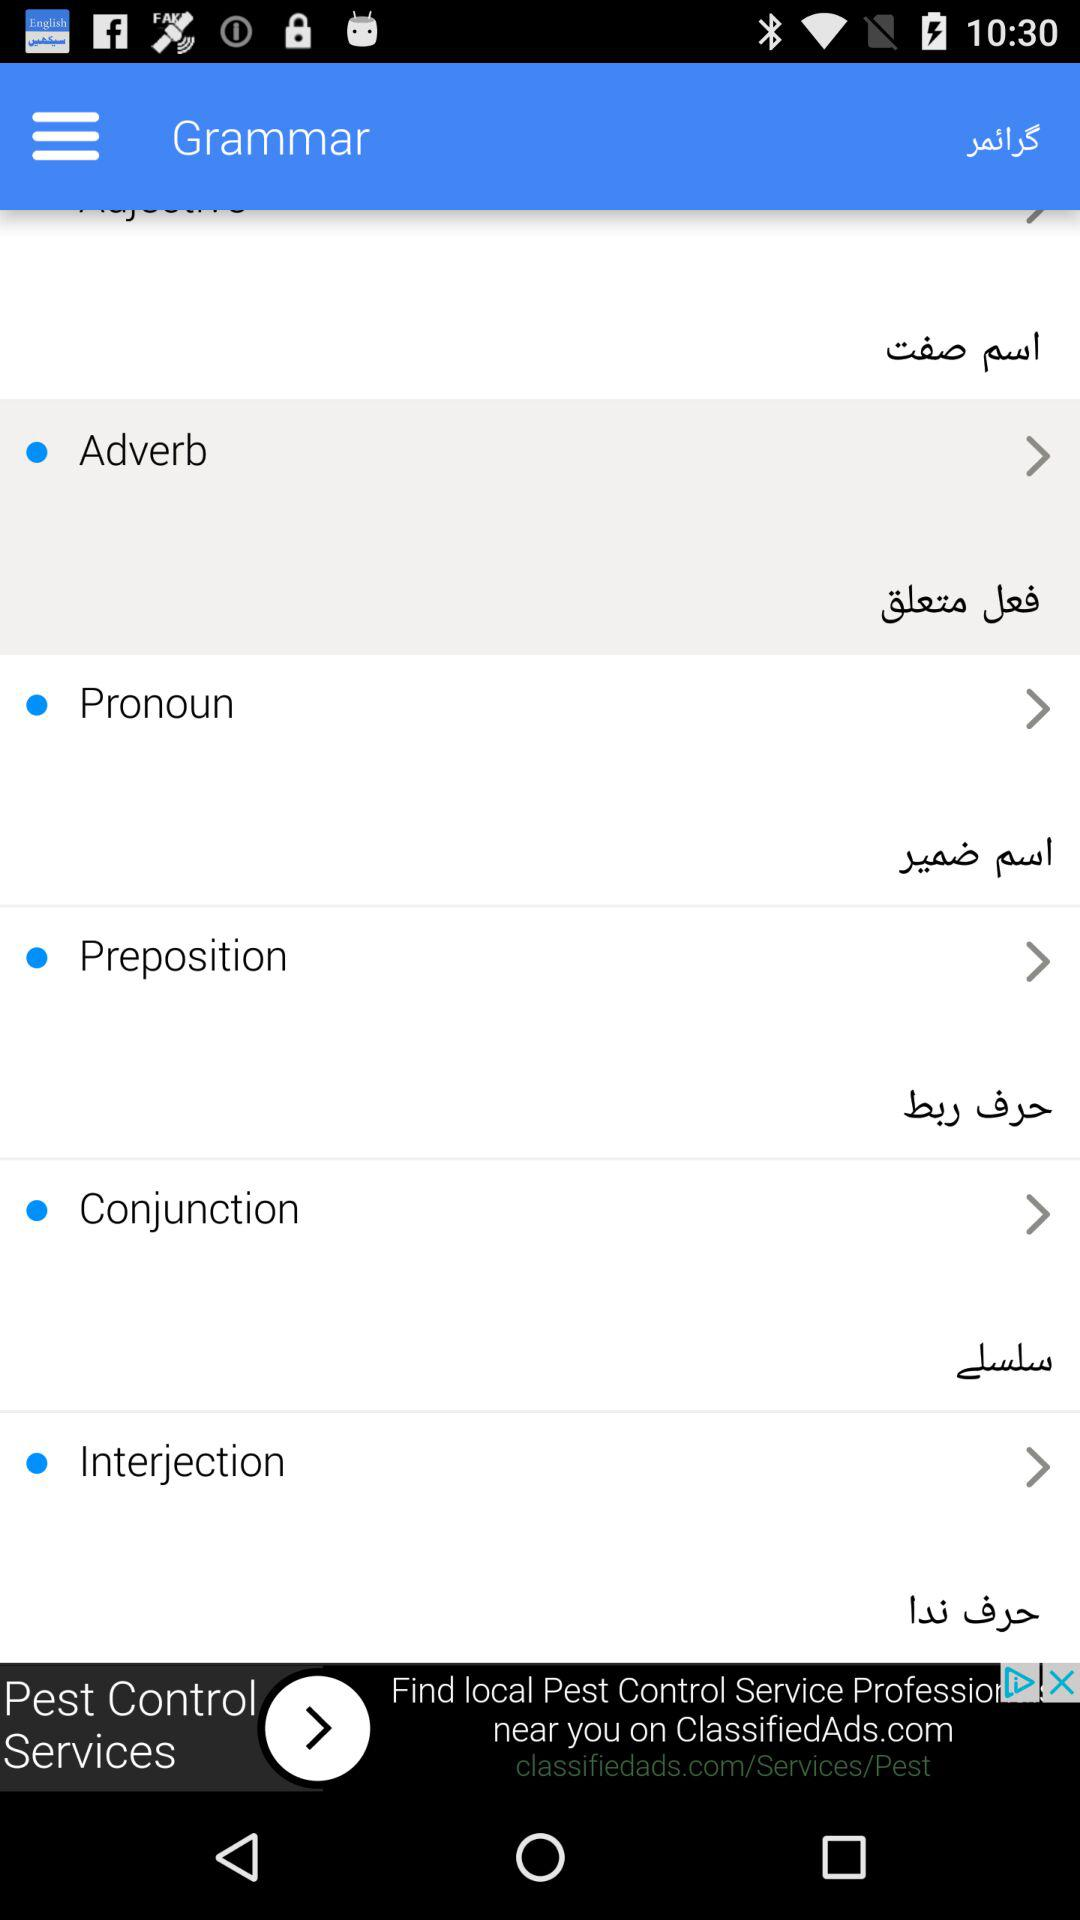What is part of speech in English? Parts of speech in English are adverbs, pronouns, prepositions, conjunctions and interjections. 